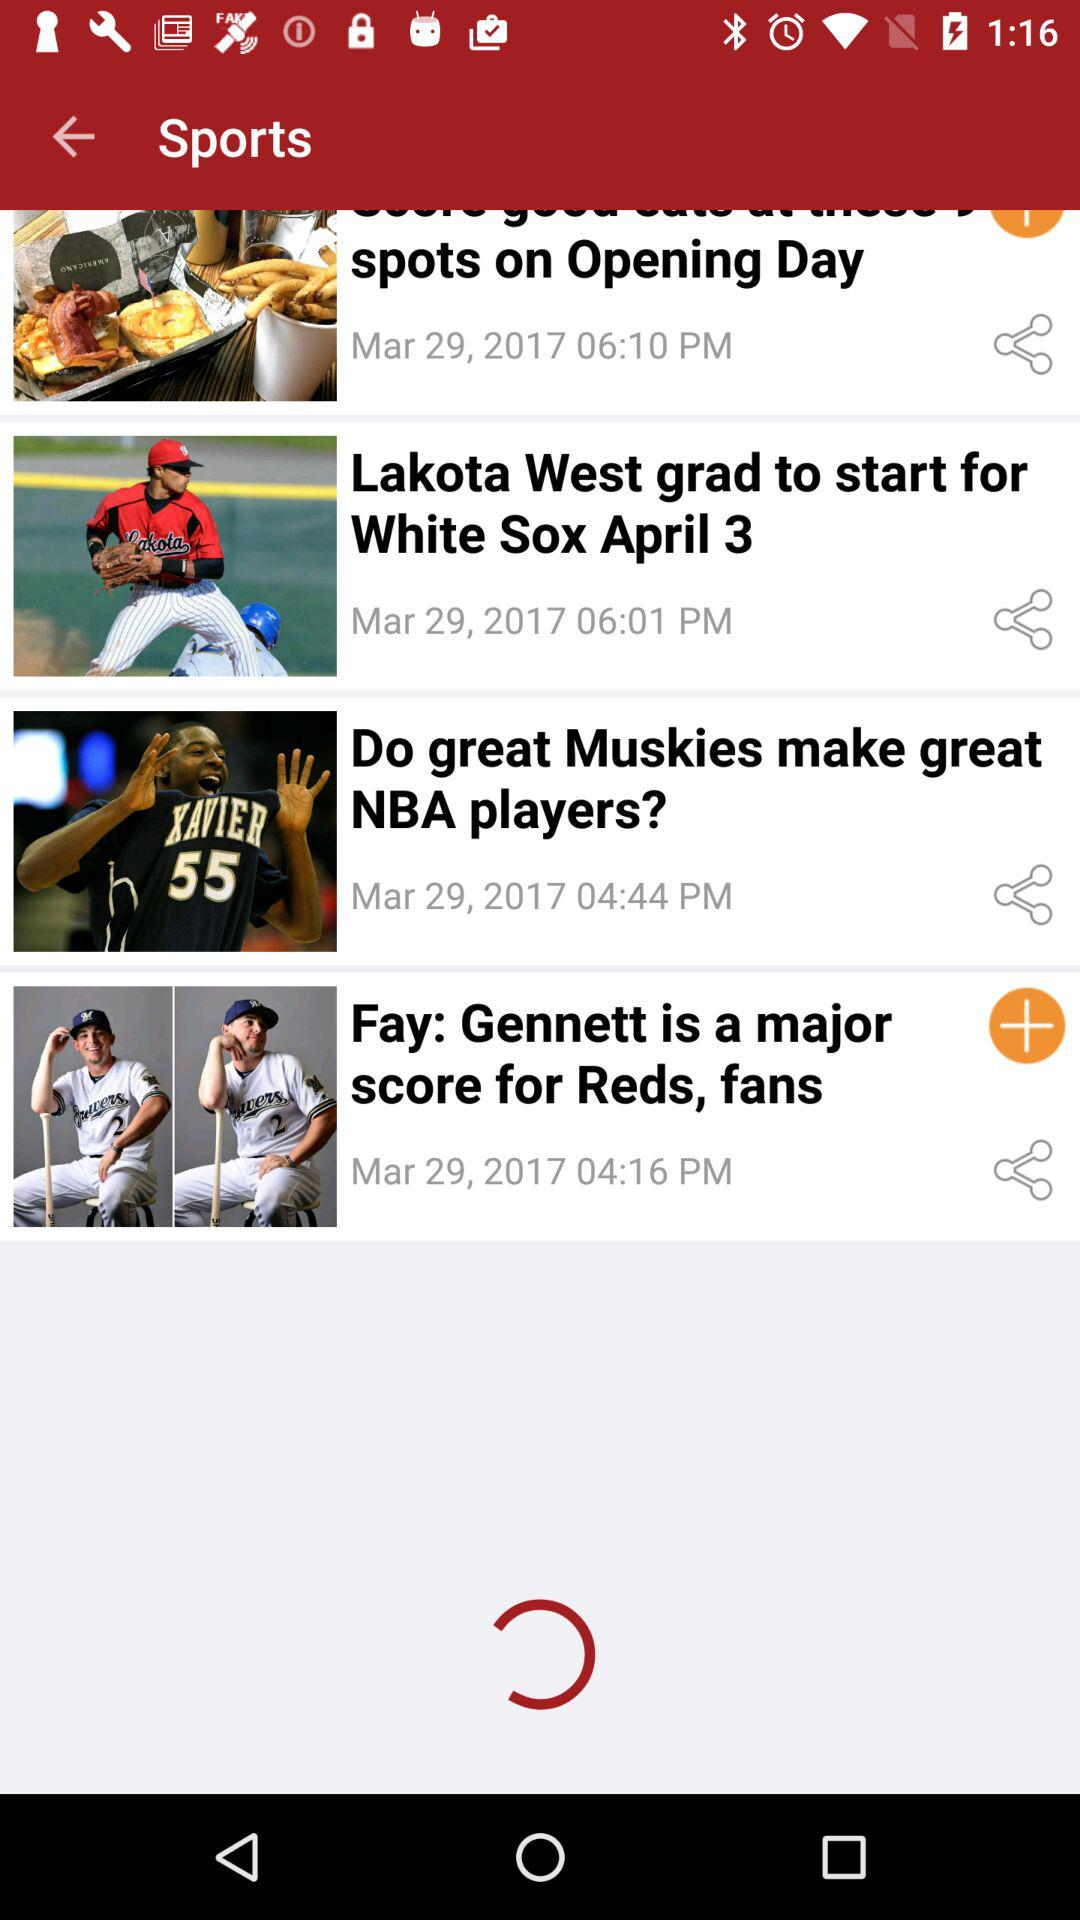When was "Lakota West grad to start for White Sox" posted? It was posted on March 29, 2017 at 06:01 PM. 